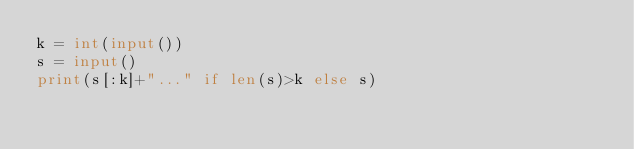Convert code to text. <code><loc_0><loc_0><loc_500><loc_500><_Python_>k = int(input())
s = input()
print(s[:k]+"..." if len(s)>k else s)</code> 